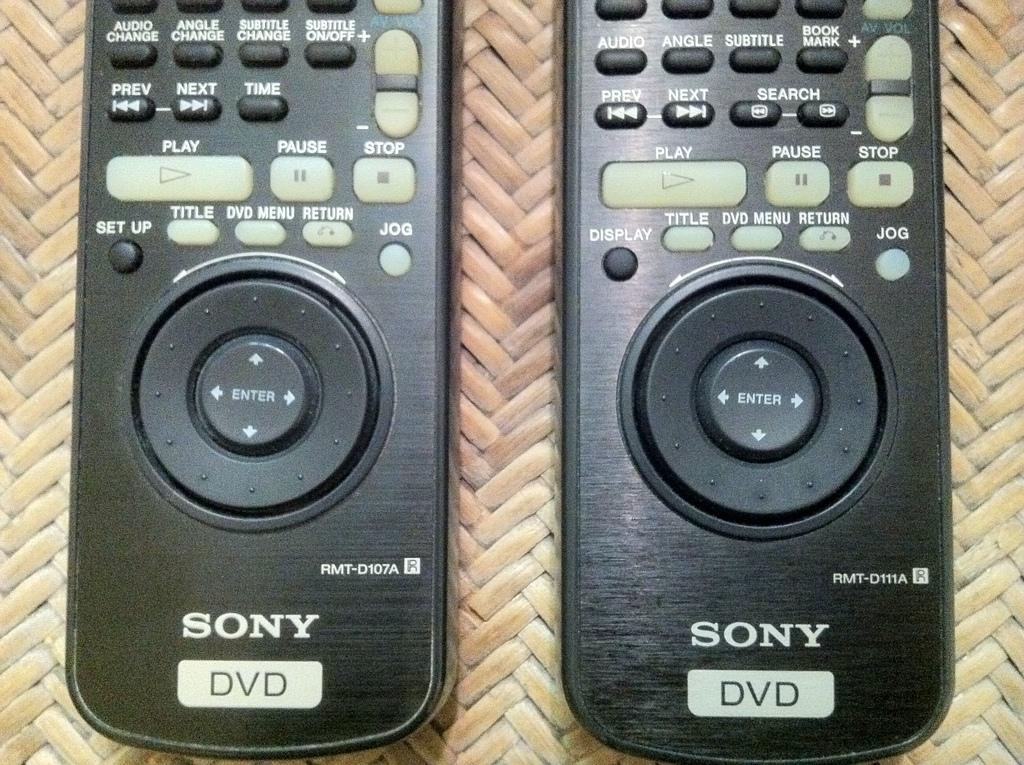Who made the remote?
Keep it short and to the point. Sony. What type of device is this remote for?
Make the answer very short. Sony. 